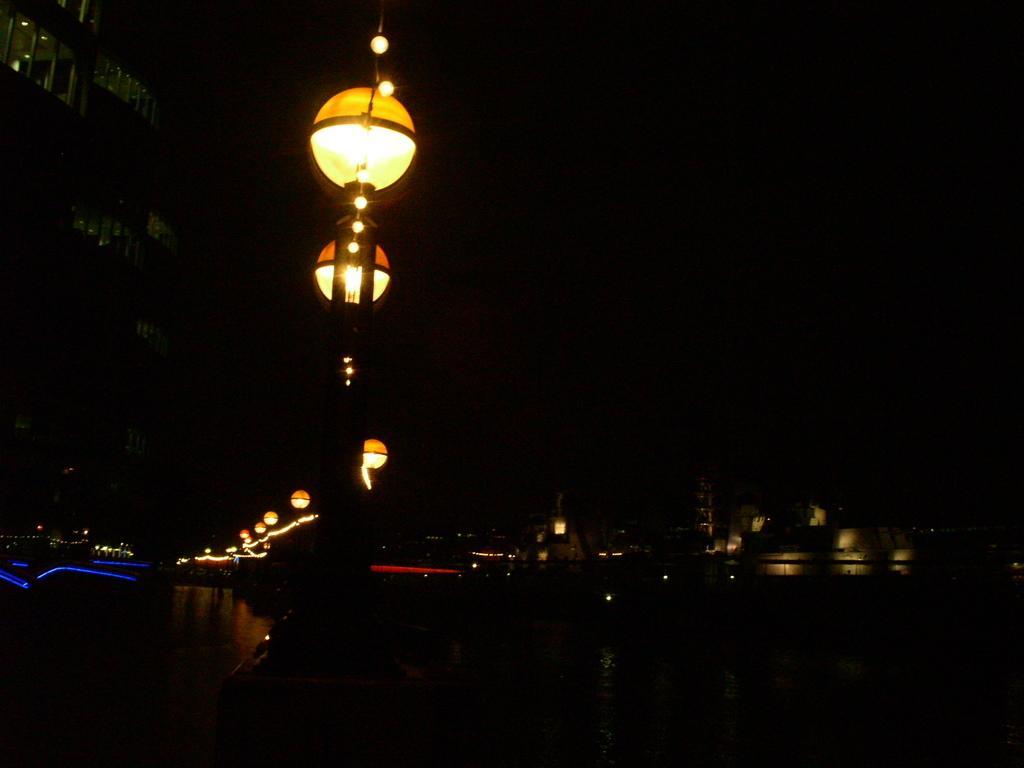In one or two sentences, can you explain what this image depicts? In the image we can see there are street light poles and there are buildings. The sky is dark and the image is little dark. 